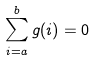Convert formula to latex. <formula><loc_0><loc_0><loc_500><loc_500>\sum _ { i = a } ^ { b } g ( i ) = 0</formula> 